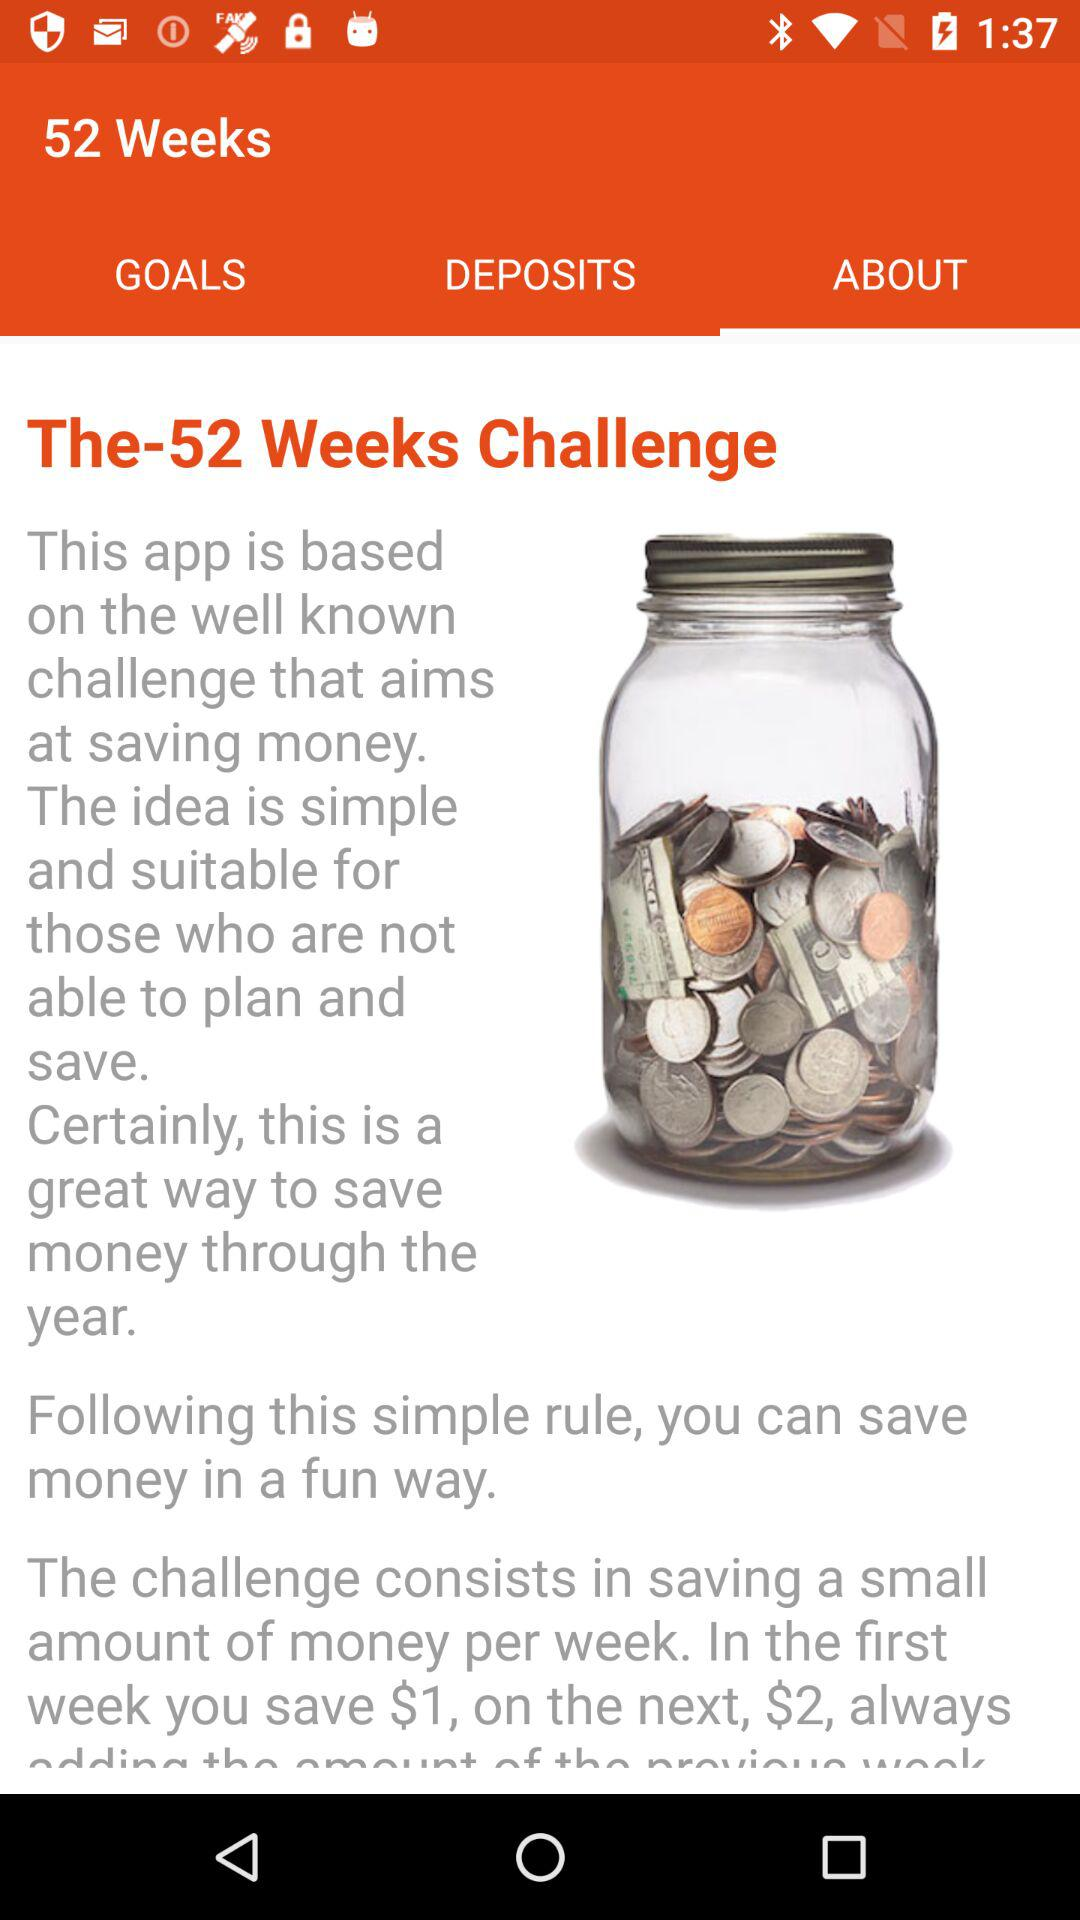How many weeks is the challenge?
Answer the question using a single word or phrase. 52 